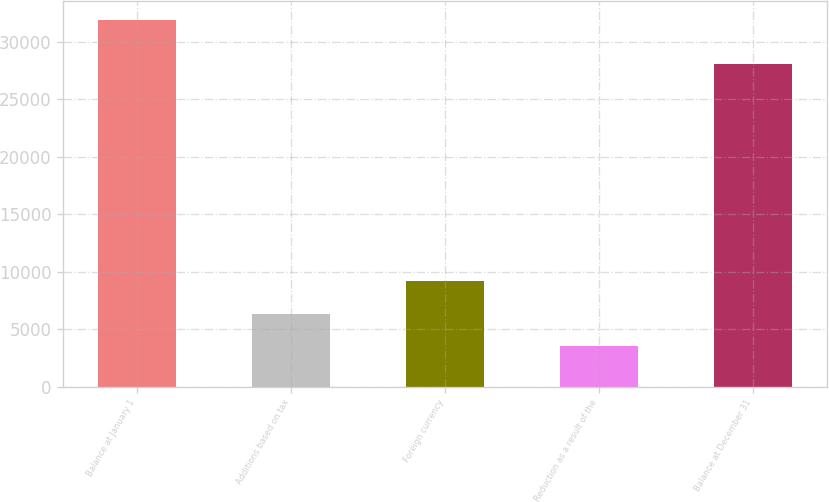<chart> <loc_0><loc_0><loc_500><loc_500><bar_chart><fcel>Balance at January 1<fcel>Additions based on tax<fcel>Foreign currency<fcel>Reduction as a result of the<fcel>Balance at December 31<nl><fcel>31947<fcel>6348.3<fcel>9192.6<fcel>3504<fcel>28114<nl></chart> 